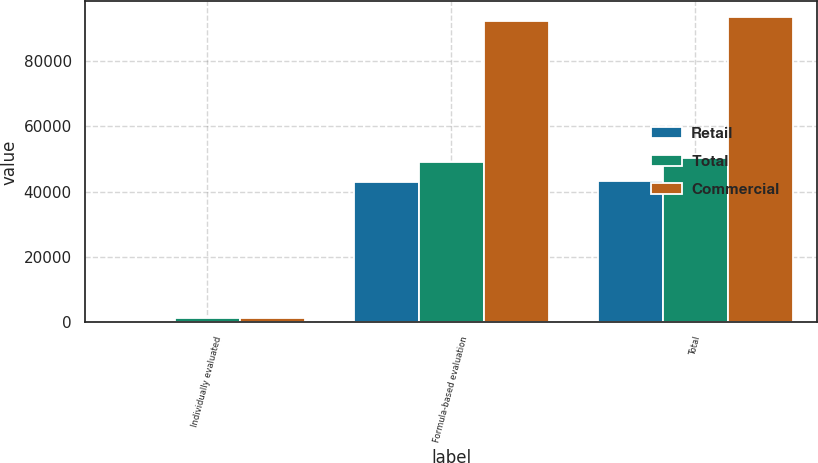Convert chart to OTSL. <chart><loc_0><loc_0><loc_500><loc_500><stacked_bar_chart><ecel><fcel>Individually evaluated<fcel>Formula-based evaluation<fcel>Total<nl><fcel>Retail<fcel>205<fcel>43021<fcel>43226<nl><fcel>Total<fcel>1208<fcel>48976<fcel>50184<nl><fcel>Commercial<fcel>1413<fcel>91997<fcel>93410<nl></chart> 